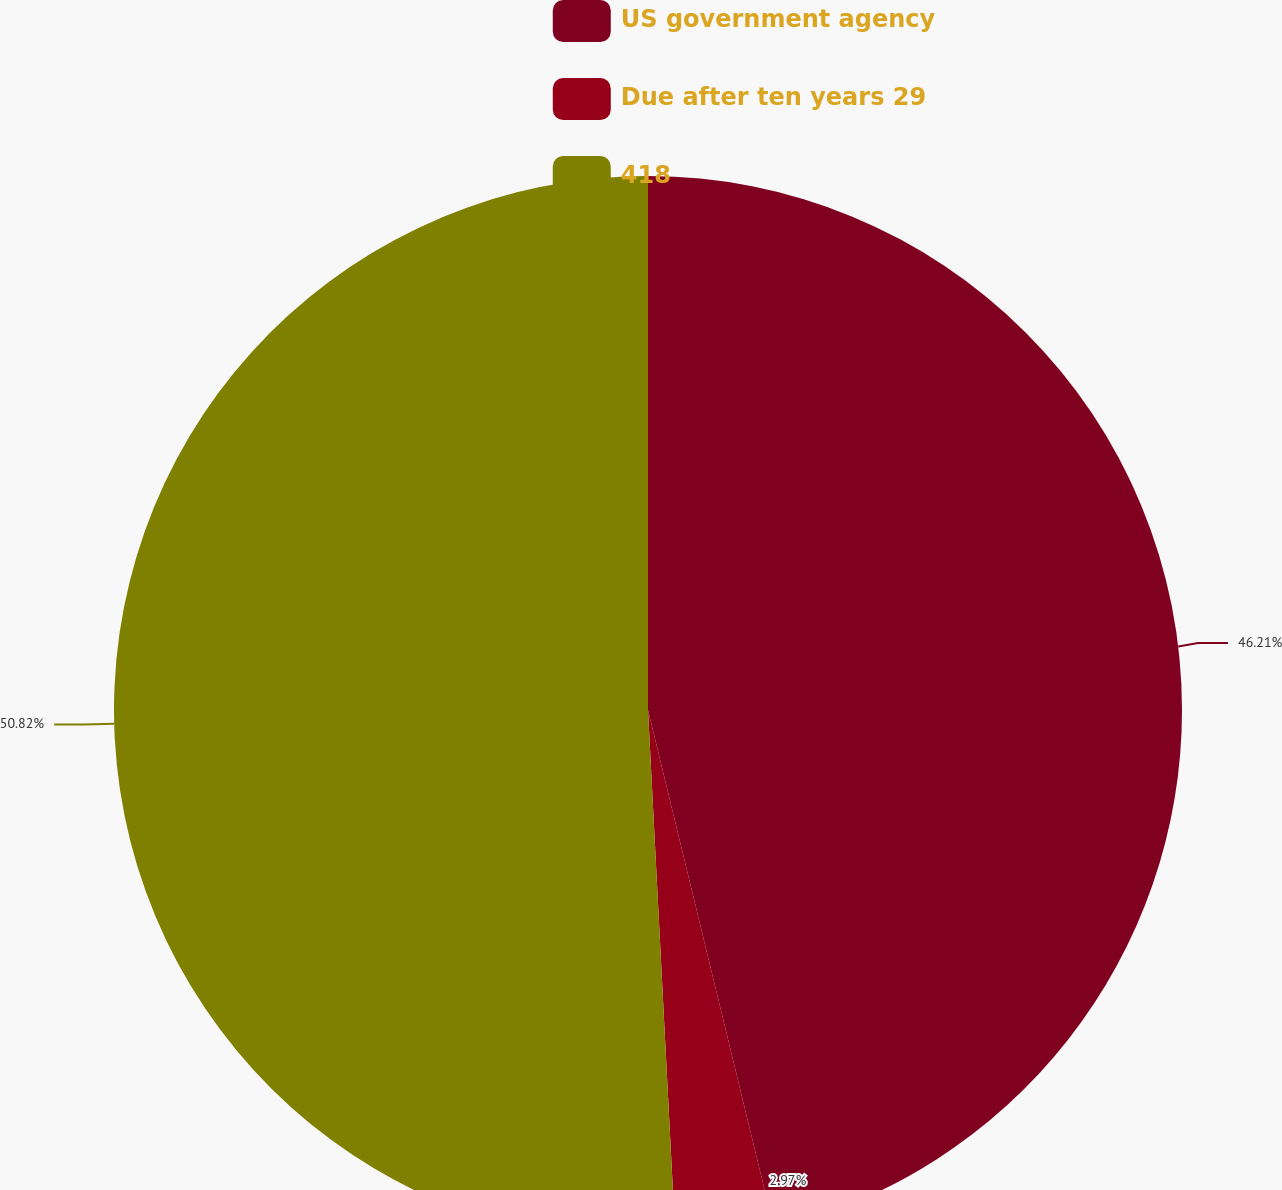Convert chart. <chart><loc_0><loc_0><loc_500><loc_500><pie_chart><fcel>US government agency<fcel>Due after ten years 29<fcel>418<nl><fcel>46.21%<fcel>2.97%<fcel>50.83%<nl></chart> 